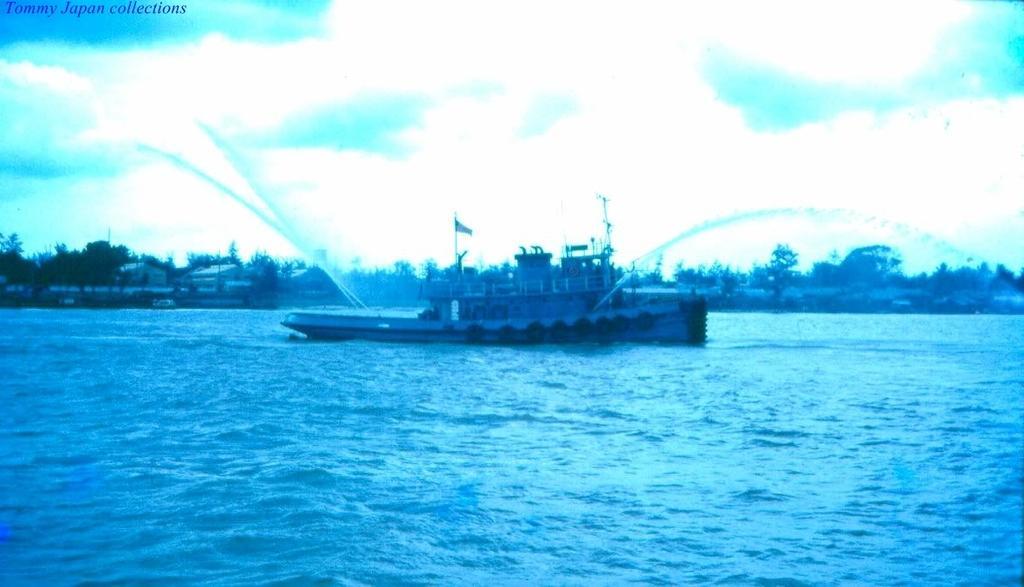How would you summarize this image in a sentence or two? In this image there is a ship in the lake and it is spraying the water in to the lake. In the background there are buildings and trees in between them. 